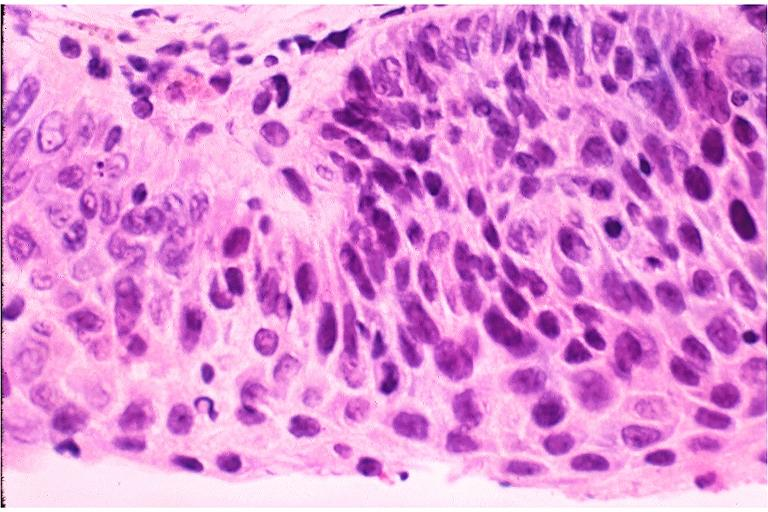where is this?
Answer the question using a single word or phrase. Oral 